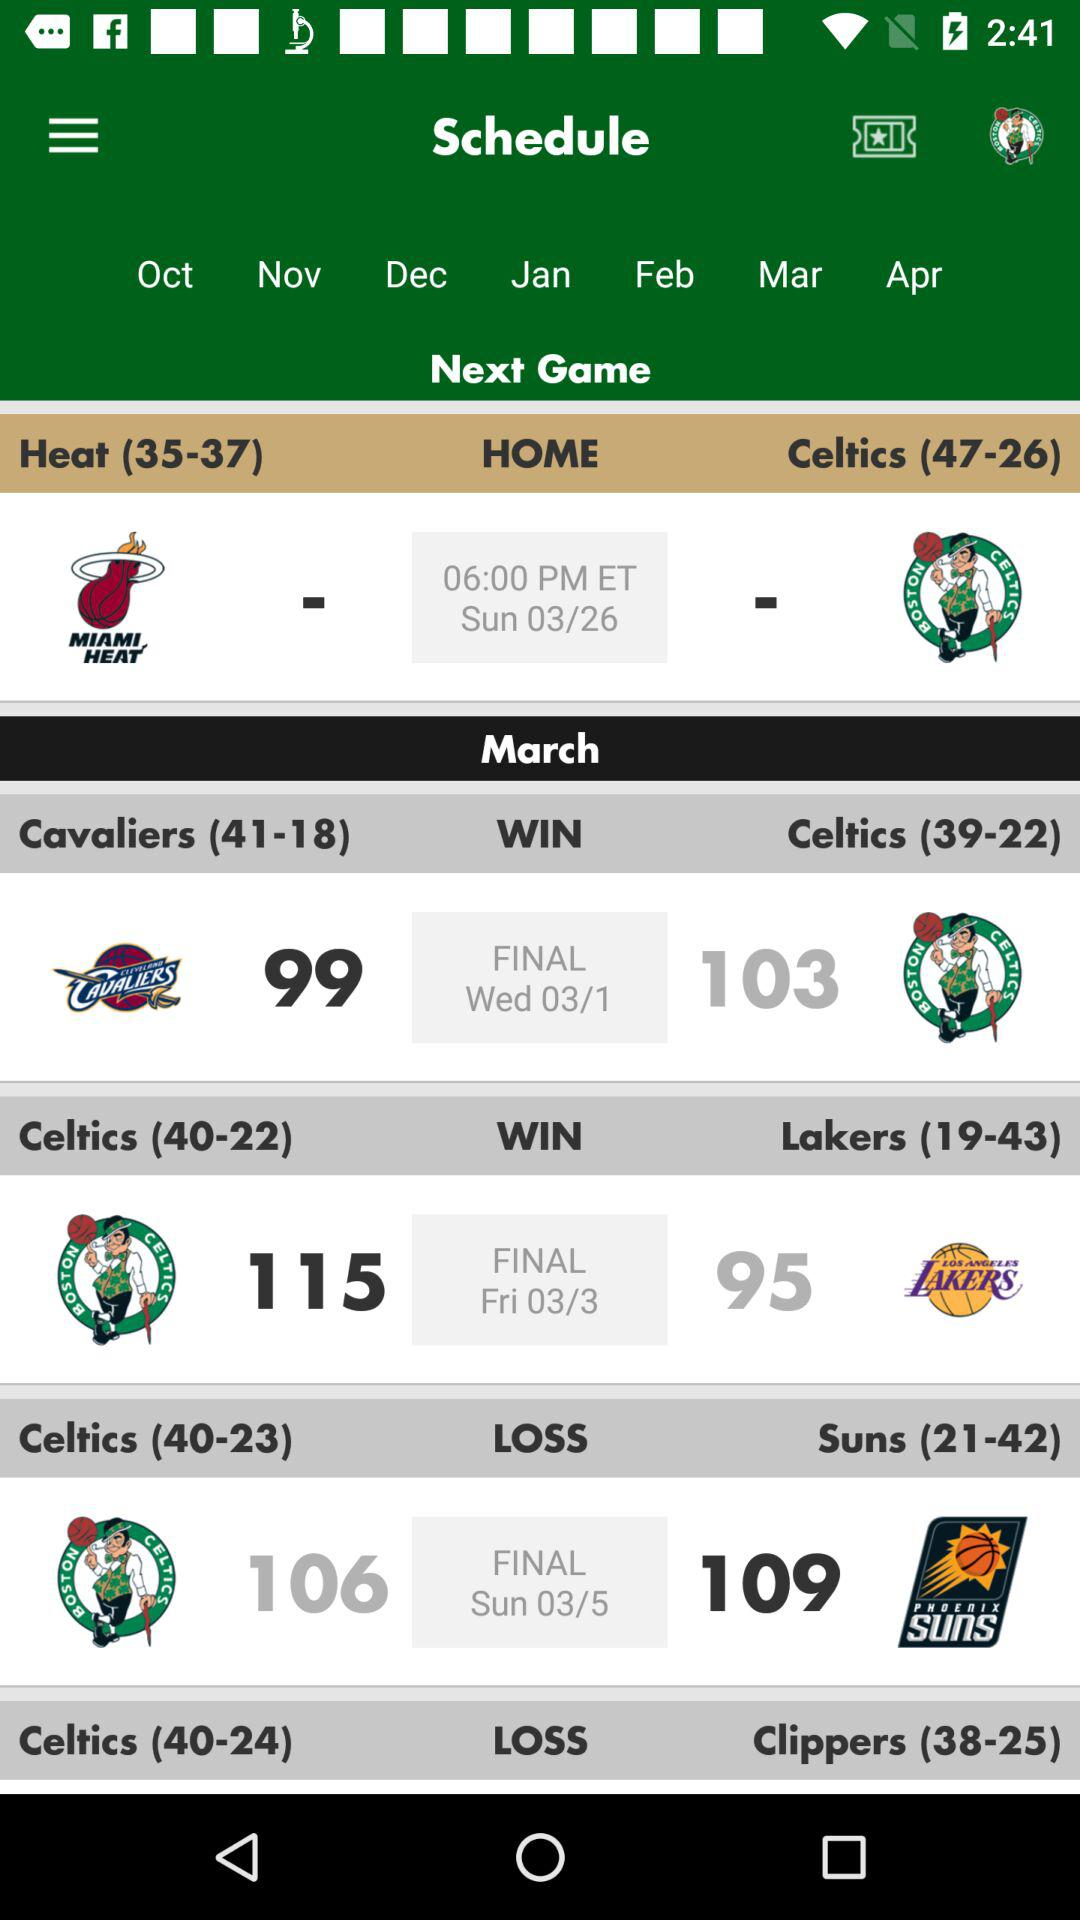How many more points did the Celtics win by in their last game against the Lakers?
Answer the question using a single word or phrase. 20 